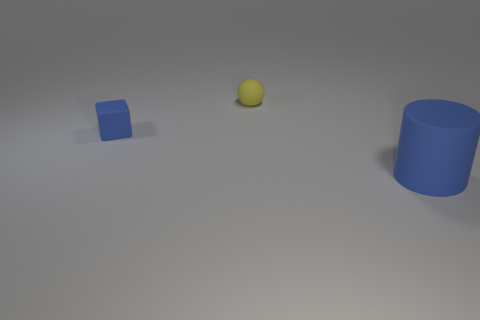What is the material of the blue cube that is the same size as the ball?
Keep it short and to the point. Rubber. Are there any yellow balls made of the same material as the big cylinder?
Make the answer very short. Yes. What is the shape of the blue rubber object on the right side of the blue matte thing on the left side of the blue rubber thing that is to the right of the small block?
Make the answer very short. Cylinder. There is a blue rubber block; does it have the same size as the matte thing behind the small block?
Keep it short and to the point. Yes. The matte thing that is both behind the blue rubber cylinder and in front of the small yellow object has what shape?
Make the answer very short. Cube. How many big things are either yellow shiny cylinders or blue things?
Your answer should be compact. 1. Is the number of cubes that are on the right side of the small sphere the same as the number of tiny rubber balls that are in front of the small blue cube?
Provide a short and direct response. Yes. How many other things are there of the same color as the small rubber cube?
Make the answer very short. 1. Are there an equal number of cylinders that are to the left of the blue rubber block and metallic balls?
Provide a succinct answer. Yes. Do the ball and the cylinder have the same size?
Your answer should be very brief. No. 